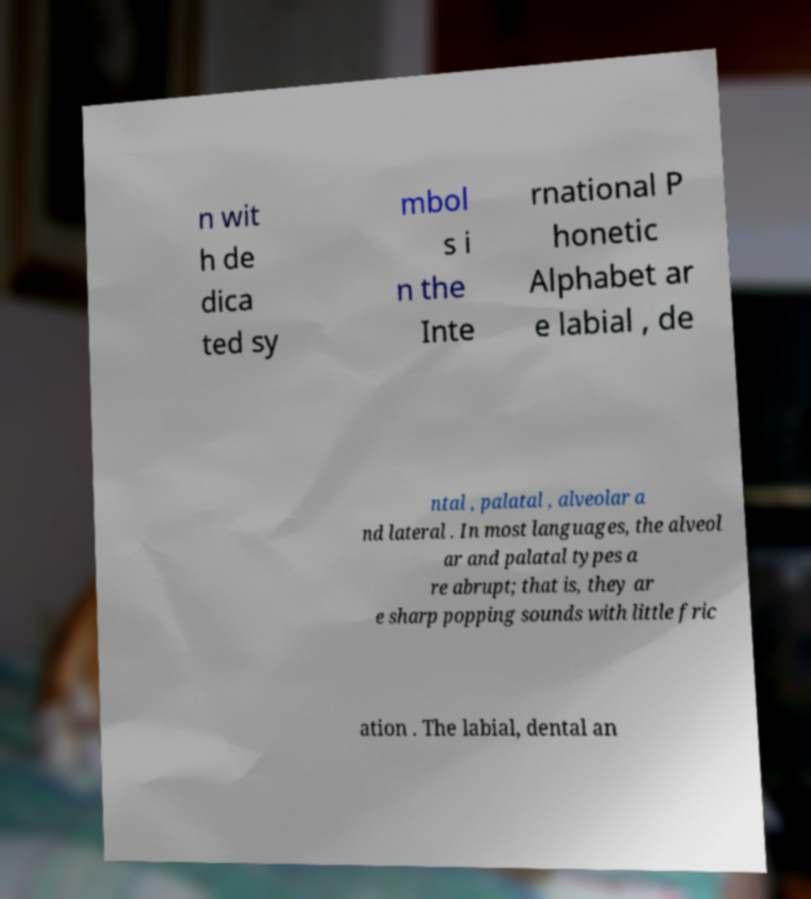Can you read and provide the text displayed in the image?This photo seems to have some interesting text. Can you extract and type it out for me? n wit h de dica ted sy mbol s i n the Inte rnational P honetic Alphabet ar e labial , de ntal , palatal , alveolar a nd lateral . In most languages, the alveol ar and palatal types a re abrupt; that is, they ar e sharp popping sounds with little fric ation . The labial, dental an 